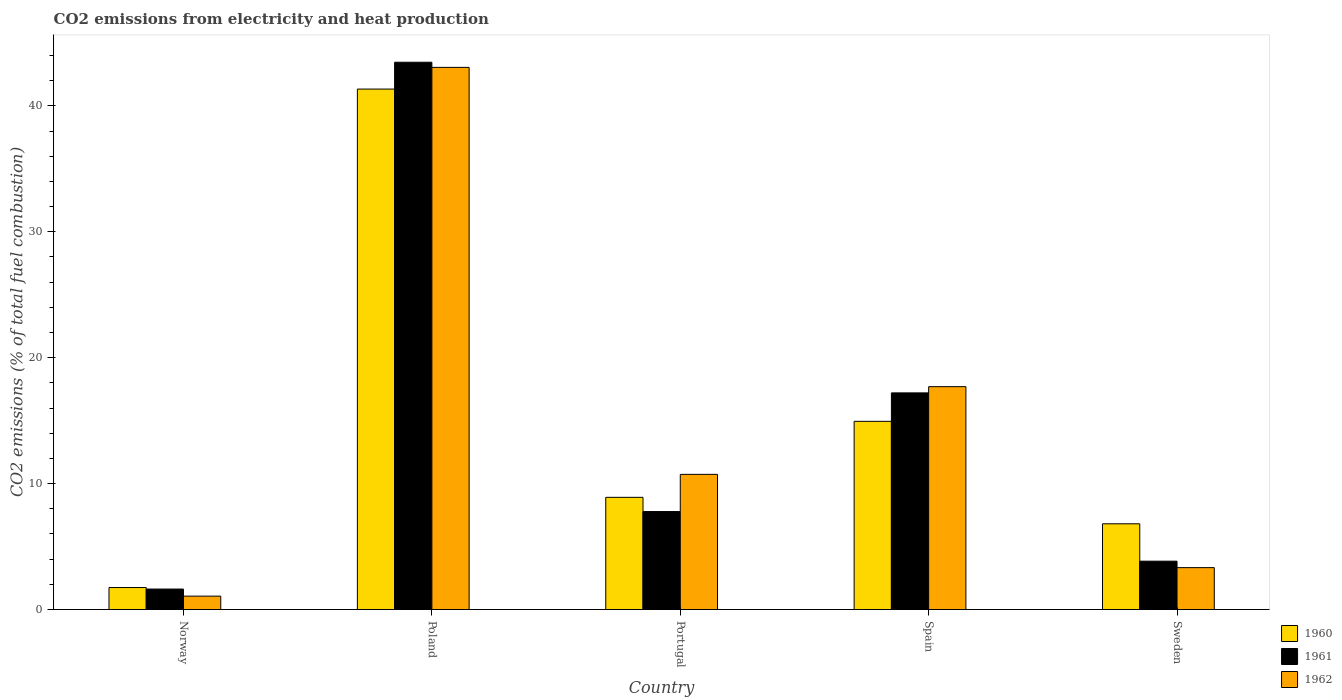How many groups of bars are there?
Keep it short and to the point. 5. Are the number of bars per tick equal to the number of legend labels?
Give a very brief answer. Yes. Are the number of bars on each tick of the X-axis equal?
Offer a terse response. Yes. What is the label of the 4th group of bars from the left?
Ensure brevity in your answer.  Spain. In how many cases, is the number of bars for a given country not equal to the number of legend labels?
Give a very brief answer. 0. What is the amount of CO2 emitted in 1960 in Sweden?
Give a very brief answer. 6.81. Across all countries, what is the maximum amount of CO2 emitted in 1961?
Offer a very short reply. 43.47. Across all countries, what is the minimum amount of CO2 emitted in 1962?
Offer a terse response. 1.06. What is the total amount of CO2 emitted in 1961 in the graph?
Your response must be concise. 73.92. What is the difference between the amount of CO2 emitted in 1962 in Portugal and that in Sweden?
Ensure brevity in your answer.  7.41. What is the difference between the amount of CO2 emitted in 1962 in Poland and the amount of CO2 emitted in 1961 in Spain?
Your answer should be very brief. 25.85. What is the average amount of CO2 emitted in 1962 per country?
Offer a very short reply. 15.18. What is the difference between the amount of CO2 emitted of/in 1962 and amount of CO2 emitted of/in 1961 in Poland?
Ensure brevity in your answer.  -0.41. In how many countries, is the amount of CO2 emitted in 1960 greater than 4 %?
Make the answer very short. 4. What is the ratio of the amount of CO2 emitted in 1961 in Norway to that in Portugal?
Make the answer very short. 0.21. Is the difference between the amount of CO2 emitted in 1962 in Portugal and Spain greater than the difference between the amount of CO2 emitted in 1961 in Portugal and Spain?
Offer a terse response. Yes. What is the difference between the highest and the second highest amount of CO2 emitted in 1962?
Offer a very short reply. 6.97. What is the difference between the highest and the lowest amount of CO2 emitted in 1960?
Offer a terse response. 39.59. In how many countries, is the amount of CO2 emitted in 1960 greater than the average amount of CO2 emitted in 1960 taken over all countries?
Make the answer very short. 2. What does the 2nd bar from the left in Poland represents?
Make the answer very short. 1961. What is the difference between two consecutive major ticks on the Y-axis?
Provide a succinct answer. 10. Does the graph contain grids?
Your answer should be very brief. No. Where does the legend appear in the graph?
Your answer should be very brief. Bottom right. What is the title of the graph?
Make the answer very short. CO2 emissions from electricity and heat production. What is the label or title of the X-axis?
Provide a short and direct response. Country. What is the label or title of the Y-axis?
Provide a succinct answer. CO2 emissions (% of total fuel combustion). What is the CO2 emissions (% of total fuel combustion) in 1960 in Norway?
Offer a terse response. 1.75. What is the CO2 emissions (% of total fuel combustion) of 1961 in Norway?
Your answer should be very brief. 1.63. What is the CO2 emissions (% of total fuel combustion) of 1962 in Norway?
Provide a succinct answer. 1.06. What is the CO2 emissions (% of total fuel combustion) of 1960 in Poland?
Your response must be concise. 41.34. What is the CO2 emissions (% of total fuel combustion) of 1961 in Poland?
Make the answer very short. 43.47. What is the CO2 emissions (% of total fuel combustion) of 1962 in Poland?
Ensure brevity in your answer.  43.06. What is the CO2 emissions (% of total fuel combustion) in 1960 in Portugal?
Your response must be concise. 8.91. What is the CO2 emissions (% of total fuel combustion) in 1961 in Portugal?
Your answer should be very brief. 7.78. What is the CO2 emissions (% of total fuel combustion) of 1962 in Portugal?
Keep it short and to the point. 10.73. What is the CO2 emissions (% of total fuel combustion) of 1960 in Spain?
Provide a succinct answer. 14.95. What is the CO2 emissions (% of total fuel combustion) in 1961 in Spain?
Give a very brief answer. 17.21. What is the CO2 emissions (% of total fuel combustion) of 1962 in Spain?
Offer a terse response. 17.7. What is the CO2 emissions (% of total fuel combustion) of 1960 in Sweden?
Your answer should be very brief. 6.81. What is the CO2 emissions (% of total fuel combustion) in 1961 in Sweden?
Provide a succinct answer. 3.84. What is the CO2 emissions (% of total fuel combustion) of 1962 in Sweden?
Your response must be concise. 3.33. Across all countries, what is the maximum CO2 emissions (% of total fuel combustion) of 1960?
Make the answer very short. 41.34. Across all countries, what is the maximum CO2 emissions (% of total fuel combustion) of 1961?
Keep it short and to the point. 43.47. Across all countries, what is the maximum CO2 emissions (% of total fuel combustion) in 1962?
Offer a terse response. 43.06. Across all countries, what is the minimum CO2 emissions (% of total fuel combustion) in 1960?
Keep it short and to the point. 1.75. Across all countries, what is the minimum CO2 emissions (% of total fuel combustion) in 1961?
Provide a succinct answer. 1.63. Across all countries, what is the minimum CO2 emissions (% of total fuel combustion) in 1962?
Keep it short and to the point. 1.06. What is the total CO2 emissions (% of total fuel combustion) in 1960 in the graph?
Provide a short and direct response. 73.75. What is the total CO2 emissions (% of total fuel combustion) in 1961 in the graph?
Offer a very short reply. 73.92. What is the total CO2 emissions (% of total fuel combustion) in 1962 in the graph?
Offer a terse response. 75.89. What is the difference between the CO2 emissions (% of total fuel combustion) in 1960 in Norway and that in Poland?
Keep it short and to the point. -39.59. What is the difference between the CO2 emissions (% of total fuel combustion) of 1961 in Norway and that in Poland?
Provide a short and direct response. -41.84. What is the difference between the CO2 emissions (% of total fuel combustion) of 1962 in Norway and that in Poland?
Give a very brief answer. -42. What is the difference between the CO2 emissions (% of total fuel combustion) of 1960 in Norway and that in Portugal?
Your answer should be compact. -7.16. What is the difference between the CO2 emissions (% of total fuel combustion) of 1961 in Norway and that in Portugal?
Make the answer very short. -6.16. What is the difference between the CO2 emissions (% of total fuel combustion) in 1962 in Norway and that in Portugal?
Your answer should be very brief. -9.67. What is the difference between the CO2 emissions (% of total fuel combustion) of 1960 in Norway and that in Spain?
Provide a short and direct response. -13.2. What is the difference between the CO2 emissions (% of total fuel combustion) in 1961 in Norway and that in Spain?
Ensure brevity in your answer.  -15.58. What is the difference between the CO2 emissions (% of total fuel combustion) in 1962 in Norway and that in Spain?
Your response must be concise. -16.64. What is the difference between the CO2 emissions (% of total fuel combustion) of 1960 in Norway and that in Sweden?
Offer a terse response. -5.06. What is the difference between the CO2 emissions (% of total fuel combustion) of 1961 in Norway and that in Sweden?
Offer a very short reply. -2.21. What is the difference between the CO2 emissions (% of total fuel combustion) in 1962 in Norway and that in Sweden?
Provide a short and direct response. -2.26. What is the difference between the CO2 emissions (% of total fuel combustion) in 1960 in Poland and that in Portugal?
Keep it short and to the point. 32.43. What is the difference between the CO2 emissions (% of total fuel combustion) in 1961 in Poland and that in Portugal?
Give a very brief answer. 35.69. What is the difference between the CO2 emissions (% of total fuel combustion) in 1962 in Poland and that in Portugal?
Provide a short and direct response. 32.33. What is the difference between the CO2 emissions (% of total fuel combustion) of 1960 in Poland and that in Spain?
Your answer should be very brief. 26.39. What is the difference between the CO2 emissions (% of total fuel combustion) in 1961 in Poland and that in Spain?
Give a very brief answer. 26.26. What is the difference between the CO2 emissions (% of total fuel combustion) in 1962 in Poland and that in Spain?
Provide a short and direct response. 25.36. What is the difference between the CO2 emissions (% of total fuel combustion) of 1960 in Poland and that in Sweden?
Your answer should be very brief. 34.53. What is the difference between the CO2 emissions (% of total fuel combustion) of 1961 in Poland and that in Sweden?
Ensure brevity in your answer.  39.63. What is the difference between the CO2 emissions (% of total fuel combustion) in 1962 in Poland and that in Sweden?
Offer a terse response. 39.73. What is the difference between the CO2 emissions (% of total fuel combustion) of 1960 in Portugal and that in Spain?
Provide a succinct answer. -6.04. What is the difference between the CO2 emissions (% of total fuel combustion) in 1961 in Portugal and that in Spain?
Offer a terse response. -9.43. What is the difference between the CO2 emissions (% of total fuel combustion) of 1962 in Portugal and that in Spain?
Give a very brief answer. -6.97. What is the difference between the CO2 emissions (% of total fuel combustion) of 1960 in Portugal and that in Sweden?
Your response must be concise. 2.1. What is the difference between the CO2 emissions (% of total fuel combustion) in 1961 in Portugal and that in Sweden?
Keep it short and to the point. 3.94. What is the difference between the CO2 emissions (% of total fuel combustion) in 1962 in Portugal and that in Sweden?
Ensure brevity in your answer.  7.41. What is the difference between the CO2 emissions (% of total fuel combustion) in 1960 in Spain and that in Sweden?
Offer a very short reply. 8.14. What is the difference between the CO2 emissions (% of total fuel combustion) in 1961 in Spain and that in Sweden?
Keep it short and to the point. 13.37. What is the difference between the CO2 emissions (% of total fuel combustion) in 1962 in Spain and that in Sweden?
Your response must be concise. 14.37. What is the difference between the CO2 emissions (% of total fuel combustion) of 1960 in Norway and the CO2 emissions (% of total fuel combustion) of 1961 in Poland?
Give a very brief answer. -41.72. What is the difference between the CO2 emissions (% of total fuel combustion) in 1960 in Norway and the CO2 emissions (% of total fuel combustion) in 1962 in Poland?
Make the answer very short. -41.31. What is the difference between the CO2 emissions (% of total fuel combustion) in 1961 in Norway and the CO2 emissions (% of total fuel combustion) in 1962 in Poland?
Provide a short and direct response. -41.44. What is the difference between the CO2 emissions (% of total fuel combustion) in 1960 in Norway and the CO2 emissions (% of total fuel combustion) in 1961 in Portugal?
Your answer should be compact. -6.03. What is the difference between the CO2 emissions (% of total fuel combustion) of 1960 in Norway and the CO2 emissions (% of total fuel combustion) of 1962 in Portugal?
Your answer should be compact. -8.99. What is the difference between the CO2 emissions (% of total fuel combustion) in 1961 in Norway and the CO2 emissions (% of total fuel combustion) in 1962 in Portugal?
Provide a succinct answer. -9.11. What is the difference between the CO2 emissions (% of total fuel combustion) in 1960 in Norway and the CO2 emissions (% of total fuel combustion) in 1961 in Spain?
Ensure brevity in your answer.  -15.46. What is the difference between the CO2 emissions (% of total fuel combustion) in 1960 in Norway and the CO2 emissions (% of total fuel combustion) in 1962 in Spain?
Your answer should be compact. -15.95. What is the difference between the CO2 emissions (% of total fuel combustion) of 1961 in Norway and the CO2 emissions (% of total fuel combustion) of 1962 in Spain?
Offer a very short reply. -16.08. What is the difference between the CO2 emissions (% of total fuel combustion) of 1960 in Norway and the CO2 emissions (% of total fuel combustion) of 1961 in Sweden?
Keep it short and to the point. -2.09. What is the difference between the CO2 emissions (% of total fuel combustion) in 1960 in Norway and the CO2 emissions (% of total fuel combustion) in 1962 in Sweden?
Ensure brevity in your answer.  -1.58. What is the difference between the CO2 emissions (% of total fuel combustion) in 1961 in Norway and the CO2 emissions (% of total fuel combustion) in 1962 in Sweden?
Keep it short and to the point. -1.7. What is the difference between the CO2 emissions (% of total fuel combustion) in 1960 in Poland and the CO2 emissions (% of total fuel combustion) in 1961 in Portugal?
Give a very brief answer. 33.56. What is the difference between the CO2 emissions (% of total fuel combustion) of 1960 in Poland and the CO2 emissions (% of total fuel combustion) of 1962 in Portugal?
Your answer should be very brief. 30.6. What is the difference between the CO2 emissions (% of total fuel combustion) in 1961 in Poland and the CO2 emissions (% of total fuel combustion) in 1962 in Portugal?
Give a very brief answer. 32.73. What is the difference between the CO2 emissions (% of total fuel combustion) of 1960 in Poland and the CO2 emissions (% of total fuel combustion) of 1961 in Spain?
Provide a succinct answer. 24.13. What is the difference between the CO2 emissions (% of total fuel combustion) in 1960 in Poland and the CO2 emissions (% of total fuel combustion) in 1962 in Spain?
Ensure brevity in your answer.  23.64. What is the difference between the CO2 emissions (% of total fuel combustion) of 1961 in Poland and the CO2 emissions (% of total fuel combustion) of 1962 in Spain?
Give a very brief answer. 25.77. What is the difference between the CO2 emissions (% of total fuel combustion) of 1960 in Poland and the CO2 emissions (% of total fuel combustion) of 1961 in Sweden?
Your answer should be compact. 37.5. What is the difference between the CO2 emissions (% of total fuel combustion) of 1960 in Poland and the CO2 emissions (% of total fuel combustion) of 1962 in Sweden?
Make the answer very short. 38.01. What is the difference between the CO2 emissions (% of total fuel combustion) in 1961 in Poland and the CO2 emissions (% of total fuel combustion) in 1962 in Sweden?
Ensure brevity in your answer.  40.14. What is the difference between the CO2 emissions (% of total fuel combustion) of 1960 in Portugal and the CO2 emissions (% of total fuel combustion) of 1961 in Spain?
Keep it short and to the point. -8.3. What is the difference between the CO2 emissions (% of total fuel combustion) in 1960 in Portugal and the CO2 emissions (% of total fuel combustion) in 1962 in Spain?
Ensure brevity in your answer.  -8.79. What is the difference between the CO2 emissions (% of total fuel combustion) of 1961 in Portugal and the CO2 emissions (% of total fuel combustion) of 1962 in Spain?
Offer a terse response. -9.92. What is the difference between the CO2 emissions (% of total fuel combustion) of 1960 in Portugal and the CO2 emissions (% of total fuel combustion) of 1961 in Sweden?
Provide a short and direct response. 5.07. What is the difference between the CO2 emissions (% of total fuel combustion) of 1960 in Portugal and the CO2 emissions (% of total fuel combustion) of 1962 in Sweden?
Offer a terse response. 5.58. What is the difference between the CO2 emissions (% of total fuel combustion) of 1961 in Portugal and the CO2 emissions (% of total fuel combustion) of 1962 in Sweden?
Offer a terse response. 4.45. What is the difference between the CO2 emissions (% of total fuel combustion) in 1960 in Spain and the CO2 emissions (% of total fuel combustion) in 1961 in Sweden?
Your response must be concise. 11.11. What is the difference between the CO2 emissions (% of total fuel combustion) of 1960 in Spain and the CO2 emissions (% of total fuel combustion) of 1962 in Sweden?
Your answer should be very brief. 11.62. What is the difference between the CO2 emissions (% of total fuel combustion) of 1961 in Spain and the CO2 emissions (% of total fuel combustion) of 1962 in Sweden?
Give a very brief answer. 13.88. What is the average CO2 emissions (% of total fuel combustion) of 1960 per country?
Make the answer very short. 14.75. What is the average CO2 emissions (% of total fuel combustion) of 1961 per country?
Keep it short and to the point. 14.78. What is the average CO2 emissions (% of total fuel combustion) in 1962 per country?
Give a very brief answer. 15.18. What is the difference between the CO2 emissions (% of total fuel combustion) of 1960 and CO2 emissions (% of total fuel combustion) of 1961 in Norway?
Ensure brevity in your answer.  0.12. What is the difference between the CO2 emissions (% of total fuel combustion) of 1960 and CO2 emissions (% of total fuel combustion) of 1962 in Norway?
Make the answer very short. 0.68. What is the difference between the CO2 emissions (% of total fuel combustion) in 1961 and CO2 emissions (% of total fuel combustion) in 1962 in Norway?
Provide a short and direct response. 0.56. What is the difference between the CO2 emissions (% of total fuel combustion) in 1960 and CO2 emissions (% of total fuel combustion) in 1961 in Poland?
Keep it short and to the point. -2.13. What is the difference between the CO2 emissions (% of total fuel combustion) in 1960 and CO2 emissions (% of total fuel combustion) in 1962 in Poland?
Make the answer very short. -1.72. What is the difference between the CO2 emissions (% of total fuel combustion) of 1961 and CO2 emissions (% of total fuel combustion) of 1962 in Poland?
Your response must be concise. 0.41. What is the difference between the CO2 emissions (% of total fuel combustion) of 1960 and CO2 emissions (% of total fuel combustion) of 1961 in Portugal?
Your answer should be very brief. 1.13. What is the difference between the CO2 emissions (% of total fuel combustion) in 1960 and CO2 emissions (% of total fuel combustion) in 1962 in Portugal?
Offer a terse response. -1.82. What is the difference between the CO2 emissions (% of total fuel combustion) of 1961 and CO2 emissions (% of total fuel combustion) of 1962 in Portugal?
Provide a short and direct response. -2.95. What is the difference between the CO2 emissions (% of total fuel combustion) in 1960 and CO2 emissions (% of total fuel combustion) in 1961 in Spain?
Give a very brief answer. -2.26. What is the difference between the CO2 emissions (% of total fuel combustion) in 1960 and CO2 emissions (% of total fuel combustion) in 1962 in Spain?
Make the answer very short. -2.75. What is the difference between the CO2 emissions (% of total fuel combustion) of 1961 and CO2 emissions (% of total fuel combustion) of 1962 in Spain?
Your answer should be compact. -0.49. What is the difference between the CO2 emissions (% of total fuel combustion) of 1960 and CO2 emissions (% of total fuel combustion) of 1961 in Sweden?
Give a very brief answer. 2.97. What is the difference between the CO2 emissions (% of total fuel combustion) of 1960 and CO2 emissions (% of total fuel combustion) of 1962 in Sweden?
Your answer should be very brief. 3.48. What is the difference between the CO2 emissions (% of total fuel combustion) of 1961 and CO2 emissions (% of total fuel combustion) of 1962 in Sweden?
Ensure brevity in your answer.  0.51. What is the ratio of the CO2 emissions (% of total fuel combustion) in 1960 in Norway to that in Poland?
Provide a succinct answer. 0.04. What is the ratio of the CO2 emissions (% of total fuel combustion) in 1961 in Norway to that in Poland?
Offer a terse response. 0.04. What is the ratio of the CO2 emissions (% of total fuel combustion) in 1962 in Norway to that in Poland?
Keep it short and to the point. 0.02. What is the ratio of the CO2 emissions (% of total fuel combustion) of 1960 in Norway to that in Portugal?
Keep it short and to the point. 0.2. What is the ratio of the CO2 emissions (% of total fuel combustion) of 1961 in Norway to that in Portugal?
Your answer should be compact. 0.21. What is the ratio of the CO2 emissions (% of total fuel combustion) in 1962 in Norway to that in Portugal?
Make the answer very short. 0.1. What is the ratio of the CO2 emissions (% of total fuel combustion) in 1960 in Norway to that in Spain?
Ensure brevity in your answer.  0.12. What is the ratio of the CO2 emissions (% of total fuel combustion) of 1961 in Norway to that in Spain?
Your response must be concise. 0.09. What is the ratio of the CO2 emissions (% of total fuel combustion) of 1962 in Norway to that in Spain?
Provide a short and direct response. 0.06. What is the ratio of the CO2 emissions (% of total fuel combustion) of 1960 in Norway to that in Sweden?
Make the answer very short. 0.26. What is the ratio of the CO2 emissions (% of total fuel combustion) of 1961 in Norway to that in Sweden?
Provide a succinct answer. 0.42. What is the ratio of the CO2 emissions (% of total fuel combustion) of 1962 in Norway to that in Sweden?
Offer a terse response. 0.32. What is the ratio of the CO2 emissions (% of total fuel combustion) in 1960 in Poland to that in Portugal?
Make the answer very short. 4.64. What is the ratio of the CO2 emissions (% of total fuel combustion) in 1961 in Poland to that in Portugal?
Keep it short and to the point. 5.59. What is the ratio of the CO2 emissions (% of total fuel combustion) of 1962 in Poland to that in Portugal?
Your response must be concise. 4.01. What is the ratio of the CO2 emissions (% of total fuel combustion) of 1960 in Poland to that in Spain?
Provide a short and direct response. 2.77. What is the ratio of the CO2 emissions (% of total fuel combustion) of 1961 in Poland to that in Spain?
Ensure brevity in your answer.  2.53. What is the ratio of the CO2 emissions (% of total fuel combustion) of 1962 in Poland to that in Spain?
Your answer should be very brief. 2.43. What is the ratio of the CO2 emissions (% of total fuel combustion) of 1960 in Poland to that in Sweden?
Provide a short and direct response. 6.07. What is the ratio of the CO2 emissions (% of total fuel combustion) of 1961 in Poland to that in Sweden?
Your answer should be very brief. 11.32. What is the ratio of the CO2 emissions (% of total fuel combustion) of 1962 in Poland to that in Sweden?
Your answer should be very brief. 12.94. What is the ratio of the CO2 emissions (% of total fuel combustion) in 1960 in Portugal to that in Spain?
Offer a very short reply. 0.6. What is the ratio of the CO2 emissions (% of total fuel combustion) of 1961 in Portugal to that in Spain?
Make the answer very short. 0.45. What is the ratio of the CO2 emissions (% of total fuel combustion) in 1962 in Portugal to that in Spain?
Keep it short and to the point. 0.61. What is the ratio of the CO2 emissions (% of total fuel combustion) of 1960 in Portugal to that in Sweden?
Ensure brevity in your answer.  1.31. What is the ratio of the CO2 emissions (% of total fuel combustion) in 1961 in Portugal to that in Sweden?
Make the answer very short. 2.03. What is the ratio of the CO2 emissions (% of total fuel combustion) in 1962 in Portugal to that in Sweden?
Make the answer very short. 3.23. What is the ratio of the CO2 emissions (% of total fuel combustion) in 1960 in Spain to that in Sweden?
Make the answer very short. 2.2. What is the ratio of the CO2 emissions (% of total fuel combustion) in 1961 in Spain to that in Sweden?
Provide a short and direct response. 4.48. What is the ratio of the CO2 emissions (% of total fuel combustion) in 1962 in Spain to that in Sweden?
Provide a succinct answer. 5.32. What is the difference between the highest and the second highest CO2 emissions (% of total fuel combustion) of 1960?
Your answer should be compact. 26.39. What is the difference between the highest and the second highest CO2 emissions (% of total fuel combustion) of 1961?
Offer a terse response. 26.26. What is the difference between the highest and the second highest CO2 emissions (% of total fuel combustion) in 1962?
Offer a terse response. 25.36. What is the difference between the highest and the lowest CO2 emissions (% of total fuel combustion) in 1960?
Give a very brief answer. 39.59. What is the difference between the highest and the lowest CO2 emissions (% of total fuel combustion) of 1961?
Your response must be concise. 41.84. What is the difference between the highest and the lowest CO2 emissions (% of total fuel combustion) in 1962?
Your answer should be compact. 42. 